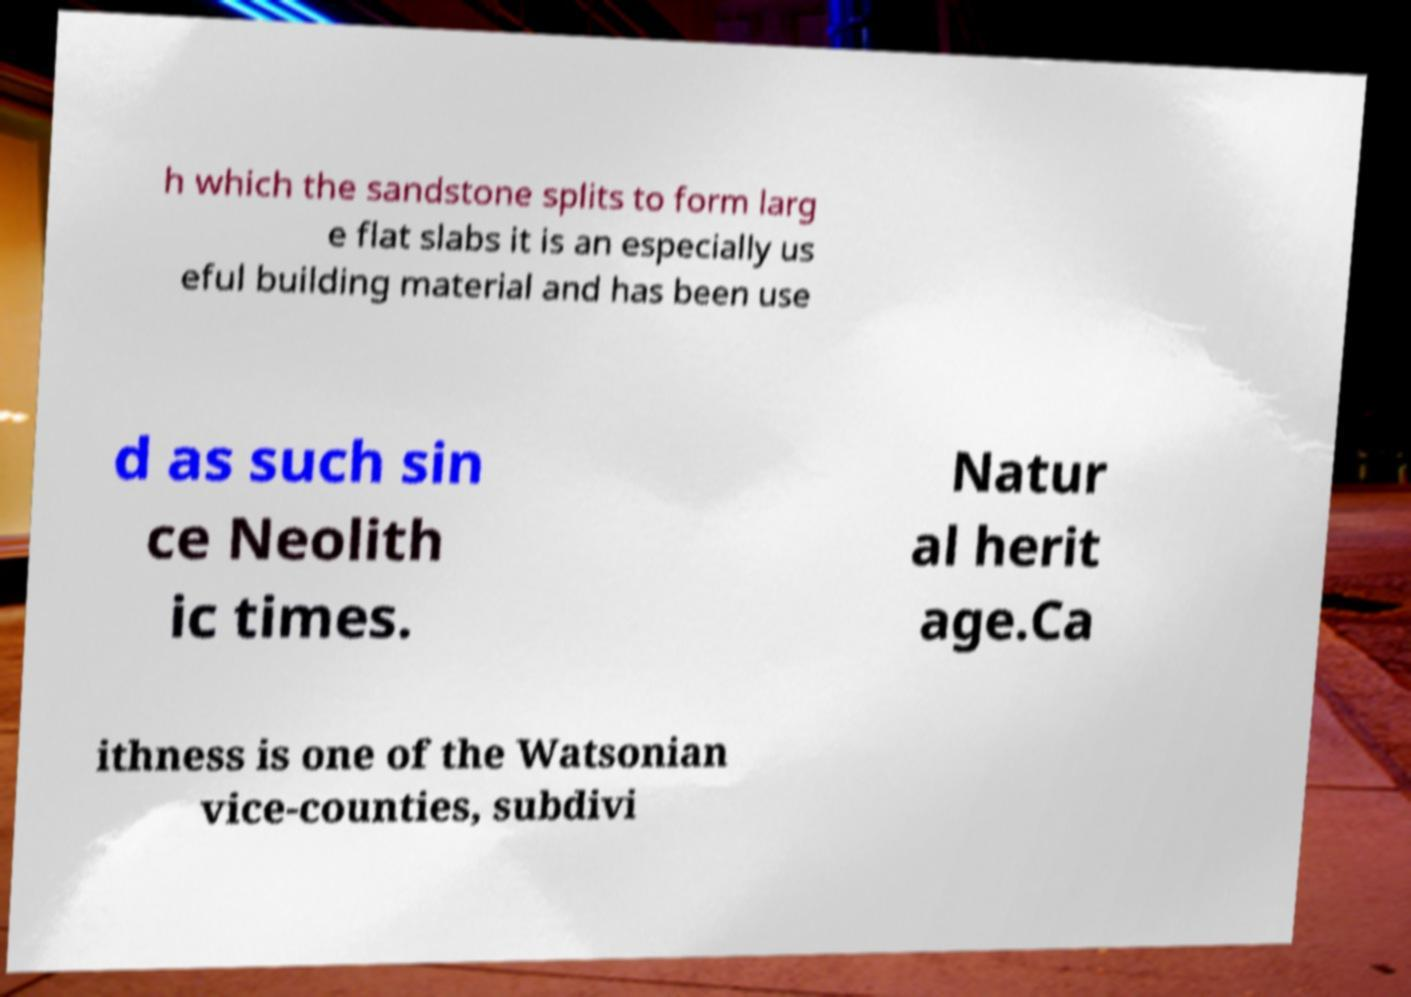For documentation purposes, I need the text within this image transcribed. Could you provide that? h which the sandstone splits to form larg e flat slabs it is an especially us eful building material and has been use d as such sin ce Neolith ic times. Natur al herit age.Ca ithness is one of the Watsonian vice-counties, subdivi 